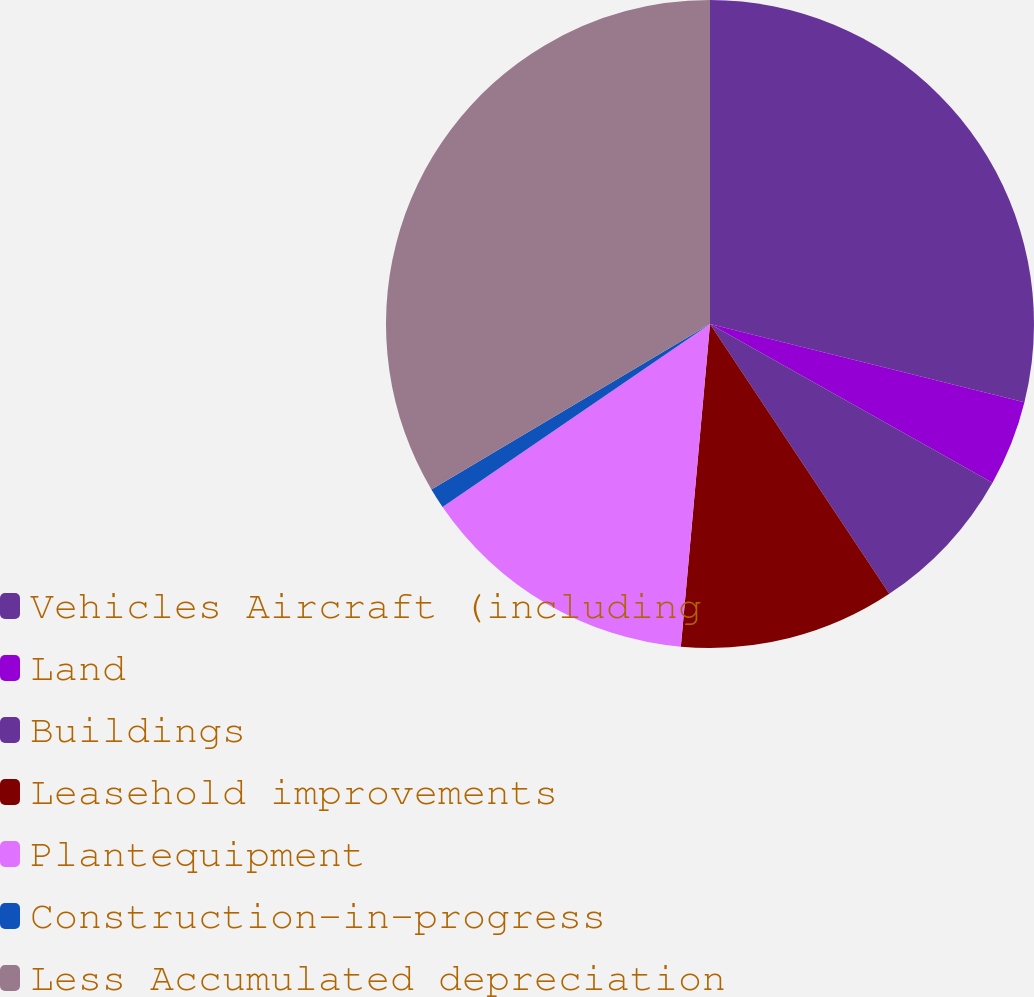Convert chart to OTSL. <chart><loc_0><loc_0><loc_500><loc_500><pie_chart><fcel>Vehicles Aircraft (including<fcel>Land<fcel>Buildings<fcel>Leasehold improvements<fcel>Plantequipment<fcel>Construction-in-progress<fcel>Less Accumulated depreciation<nl><fcel>28.88%<fcel>4.27%<fcel>7.52%<fcel>10.77%<fcel>14.02%<fcel>1.02%<fcel>33.53%<nl></chart> 